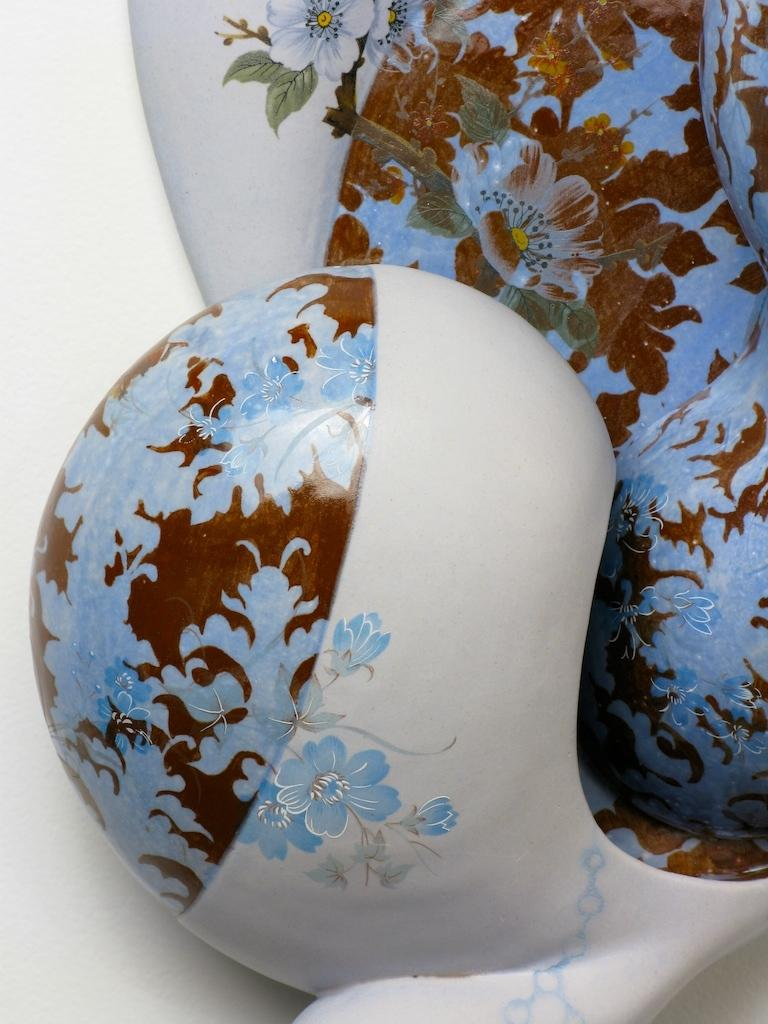What can be observed about the objects in the image? There are designs on objects in the image. What color is the background of the image? The background of the image is white. How many toads can be seen in the image? There are no toads present in the image. What type of wood is used to create the designs in the image? There is no wood or indication of wood being used to create the designs in the image. 